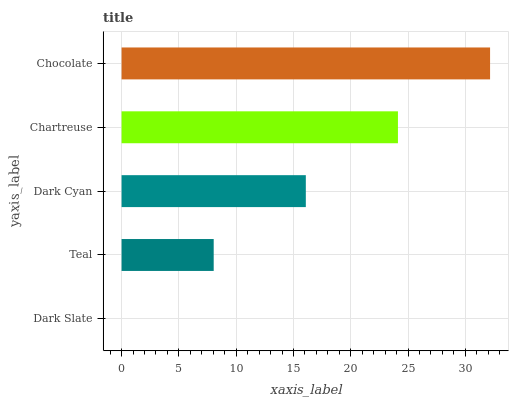Is Dark Slate the minimum?
Answer yes or no. Yes. Is Chocolate the maximum?
Answer yes or no. Yes. Is Teal the minimum?
Answer yes or no. No. Is Teal the maximum?
Answer yes or no. No. Is Teal greater than Dark Slate?
Answer yes or no. Yes. Is Dark Slate less than Teal?
Answer yes or no. Yes. Is Dark Slate greater than Teal?
Answer yes or no. No. Is Teal less than Dark Slate?
Answer yes or no. No. Is Dark Cyan the high median?
Answer yes or no. Yes. Is Dark Cyan the low median?
Answer yes or no. Yes. Is Chocolate the high median?
Answer yes or no. No. Is Teal the low median?
Answer yes or no. No. 